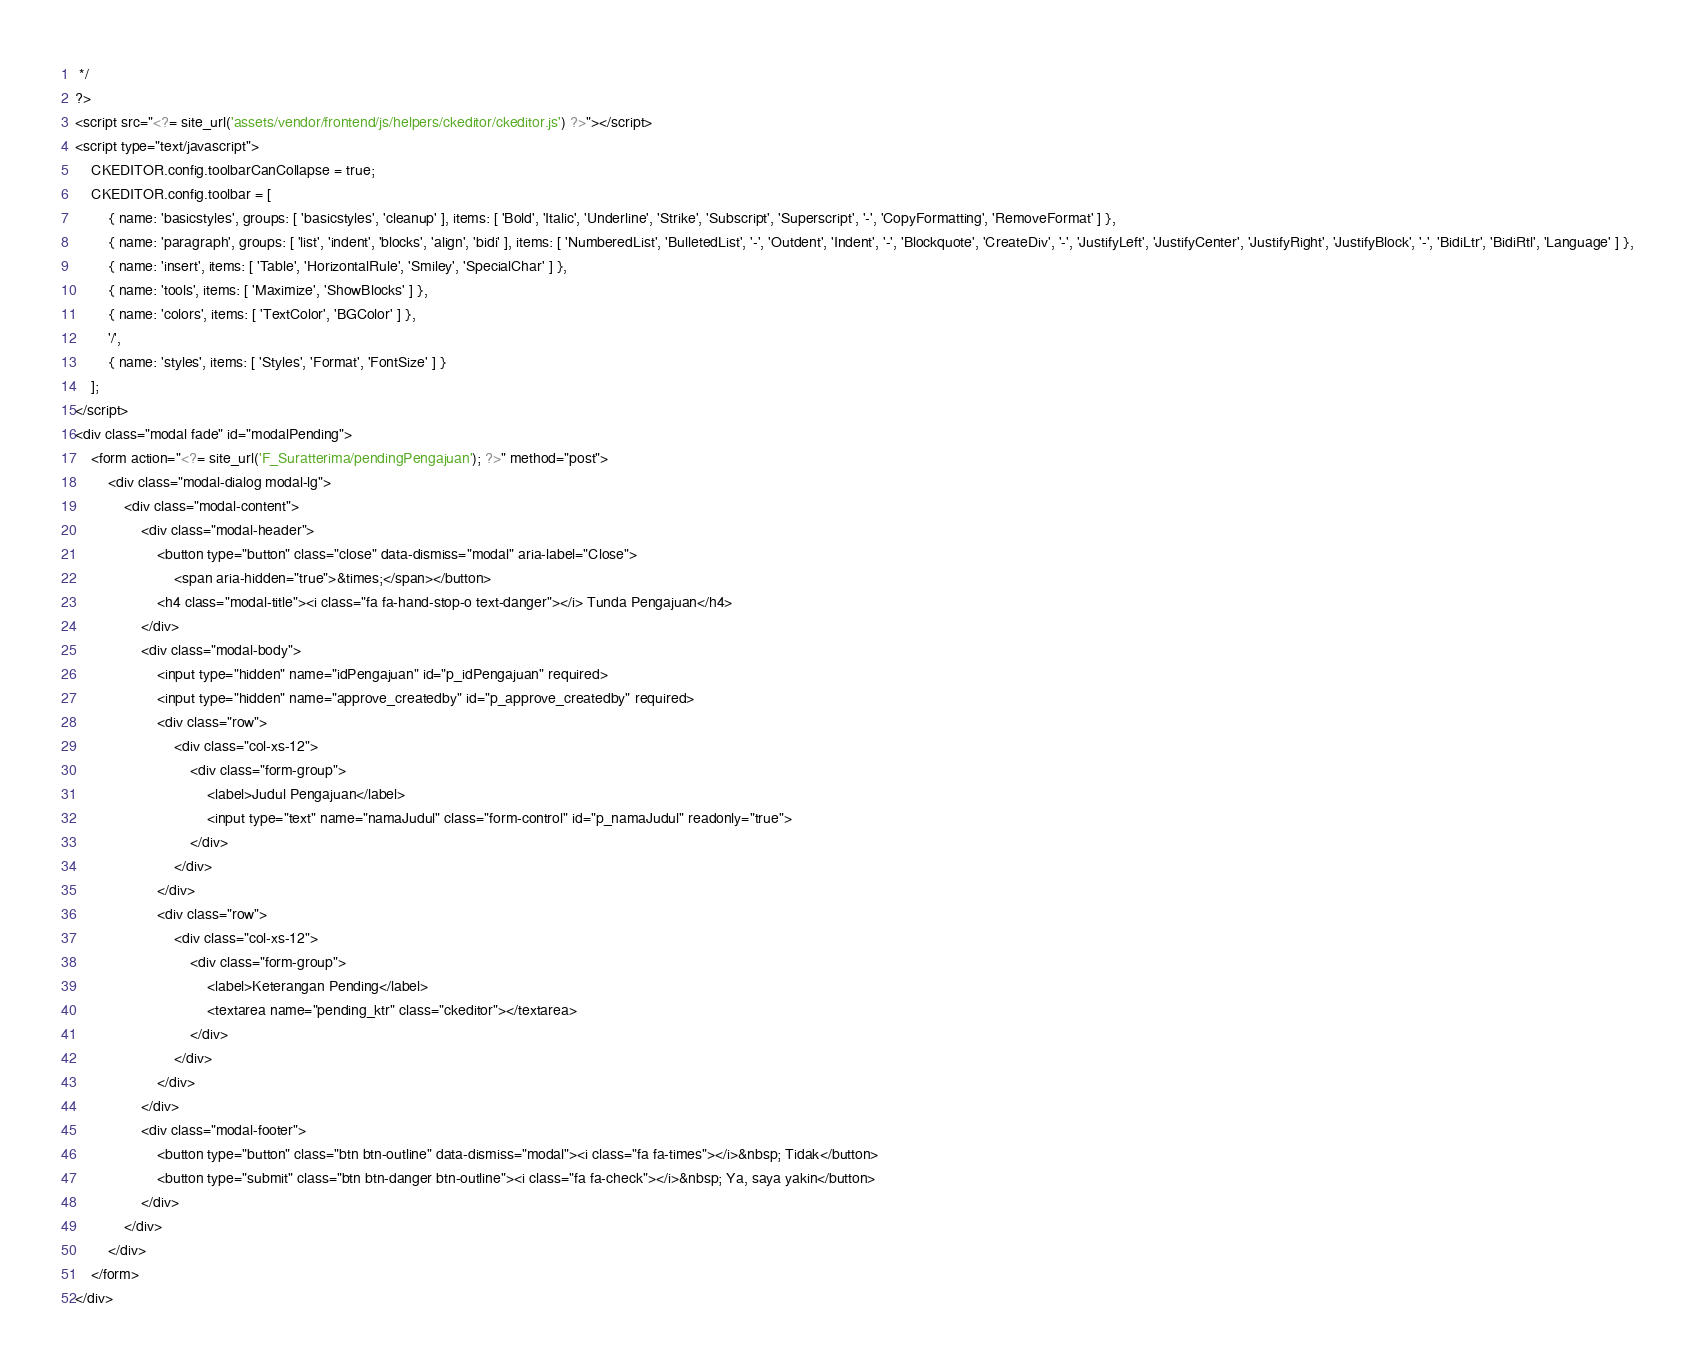Convert code to text. <code><loc_0><loc_0><loc_500><loc_500><_PHP_> */
?>
<script src="<?= site_url('assets/vendor/frontend/js/helpers/ckeditor/ckeditor.js') ?>"></script>
<script type="text/javascript">
    CKEDITOR.config.toolbarCanCollapse = true;
    CKEDITOR.config.toolbar = [
        { name: 'basicstyles', groups: [ 'basicstyles', 'cleanup' ], items: [ 'Bold', 'Italic', 'Underline', 'Strike', 'Subscript', 'Superscript', '-', 'CopyFormatting', 'RemoveFormat' ] },
        { name: 'paragraph', groups: [ 'list', 'indent', 'blocks', 'align', 'bidi' ], items: [ 'NumberedList', 'BulletedList', '-', 'Outdent', 'Indent', '-', 'Blockquote', 'CreateDiv', '-', 'JustifyLeft', 'JustifyCenter', 'JustifyRight', 'JustifyBlock', '-', 'BidiLtr', 'BidiRtl', 'Language' ] },
        { name: 'insert', items: [ 'Table', 'HorizontalRule', 'Smiley', 'SpecialChar' ] },
        { name: 'tools', items: [ 'Maximize', 'ShowBlocks' ] },
        { name: 'colors', items: [ 'TextColor', 'BGColor' ] },
        '/',
        { name: 'styles', items: [ 'Styles', 'Format', 'FontSize' ] }
    ];
</script>
<div class="modal fade" id="modalPending">
    <form action="<?= site_url('F_Suratterima/pendingPengajuan'); ?>" method="post">
        <div class="modal-dialog modal-lg">
            <div class="modal-content">
                <div class="modal-header">
                    <button type="button" class="close" data-dismiss="modal" aria-label="Close">
                        <span aria-hidden="true">&times;</span></button>
                    <h4 class="modal-title"><i class="fa fa-hand-stop-o text-danger"></i> Tunda Pengajuan</h4>
                </div>
                <div class="modal-body">
                    <input type="hidden" name="idPengajuan" id="p_idPengajuan" required>
                    <input type="hidden" name="approve_createdby" id="p_approve_createdby" required>
                    <div class="row">
                        <div class="col-xs-12">
                            <div class="form-group">
                                <label>Judul Pengajuan</label>
                                <input type="text" name="namaJudul" class="form-control" id="p_namaJudul" readonly="true">
                            </div>
                        </div>
                    </div>
                    <div class="row">
                        <div class="col-xs-12">
                            <div class="form-group">
                                <label>Keterangan Pending</label>
                                <textarea name="pending_ktr" class="ckeditor"></textarea>
                            </div>
                        </div>
                    </div>
                </div>
                <div class="modal-footer">
                    <button type="button" class="btn btn-outline" data-dismiss="modal"><i class="fa fa-times"></i>&nbsp; Tidak</button>
                    <button type="submit" class="btn btn-danger btn-outline"><i class="fa fa-check"></i>&nbsp; Ya, saya yakin</button>
                </div>
            </div>
        </div>
    </form>
</div>
</code> 